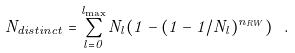Convert formula to latex. <formula><loc_0><loc_0><loc_500><loc_500>N _ { d i s t i n c t } = \sum _ { l = 0 } ^ { l _ { \max } } N _ { l } ( 1 - ( 1 - 1 / N _ { l } ) ^ { n _ { R W } } ) \ .</formula> 